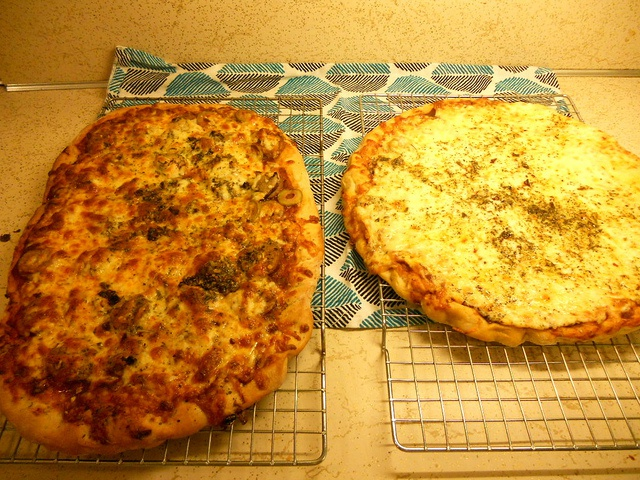Describe the objects in this image and their specific colors. I can see pizza in maroon, red, and orange tones and pizza in maroon, khaki, orange, gold, and red tones in this image. 